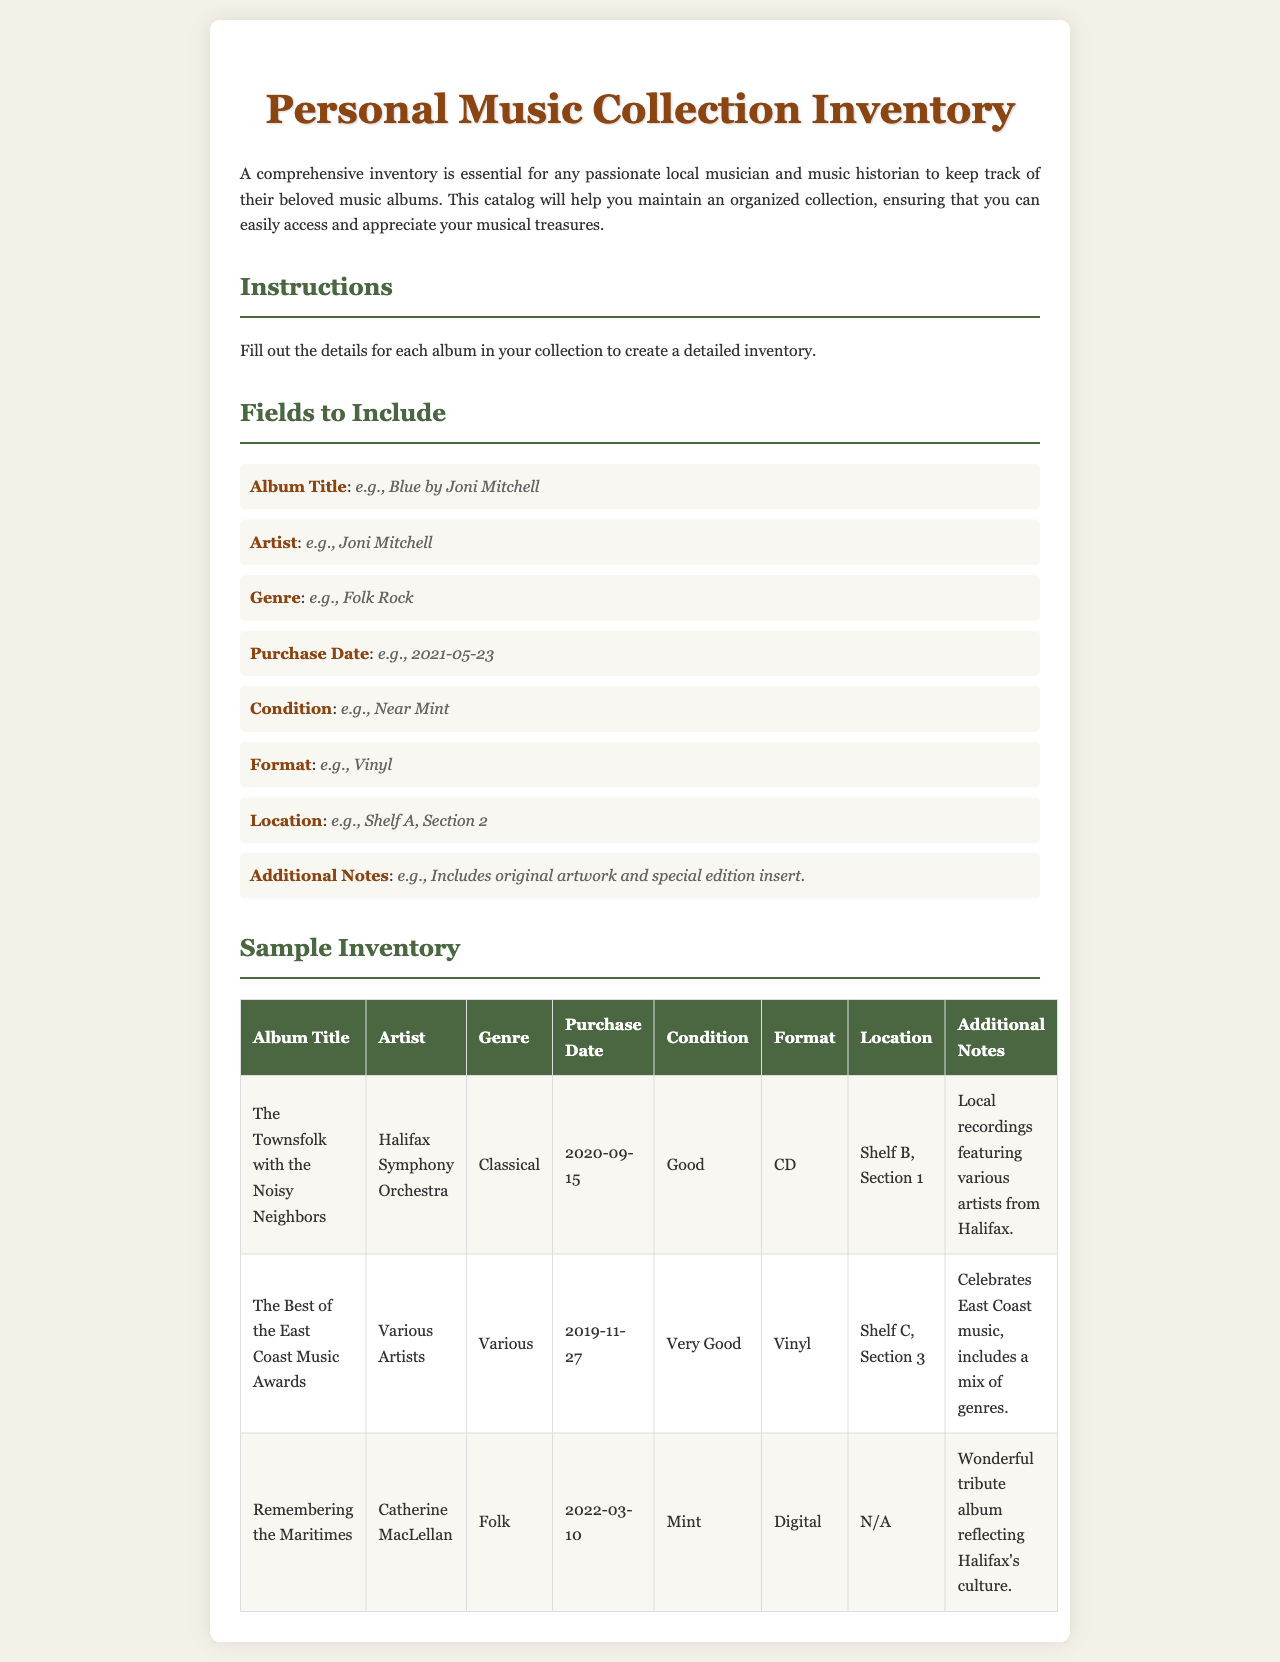what is the title of the first album listed? The first album listed in the sample inventory is "The Townsfolk with the Noisy Neighbors."
Answer: The Townsfolk with the Noisy Neighbors who is the artist of "Remembering the Maritimes"? The artist of "Remembering the Maritimes" is Catherine MacLellan.
Answer: Catherine MacLellan when was "The Best of the East Coast Music Awards" purchased? The purchase date for "The Best of the East Coast Music Awards" is listed as 2019-11-27.
Answer: 2019-11-27 what genre does "The Townsfolk with the Noisy Neighbors" belong to? The genre for "The Townsfolk with the Noisy Neighbors" is Classical.
Answer: Classical which album has a condition rated as Mint? The album with a condition rated as Mint is "Remembering the Maritimes."
Answer: Remembering the Maritimes how many albums are listed in the sample inventory? The sample inventory lists a total of three albums.
Answer: 3 what format is "The Best of the East Coast Music Awards"? The format of "The Best of the East Coast Music Awards" is Vinyl.
Answer: Vinyl what is the additional note regarding "Remembering the Maritimes"? The additional note states that it is a wonderful tribute album reflecting Halifax's culture.
Answer: Wonderful tribute album reflecting Halifax's culture where can "The Townsfolk with the Noisy Neighbors" be found? "The Townsfolk with the Noisy Neighbors" can be found on Shelf B, Section 1.
Answer: Shelf B, Section 1 